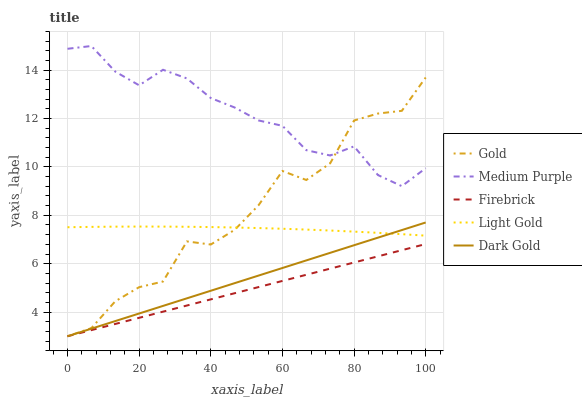Does Firebrick have the minimum area under the curve?
Answer yes or no. Yes. Does Medium Purple have the maximum area under the curve?
Answer yes or no. Yes. Does Light Gold have the minimum area under the curve?
Answer yes or no. No. Does Light Gold have the maximum area under the curve?
Answer yes or no. No. Is Dark Gold the smoothest?
Answer yes or no. Yes. Is Gold the roughest?
Answer yes or no. Yes. Is Firebrick the smoothest?
Answer yes or no. No. Is Firebrick the roughest?
Answer yes or no. No. Does Firebrick have the lowest value?
Answer yes or no. Yes. Does Light Gold have the lowest value?
Answer yes or no. No. Does Medium Purple have the highest value?
Answer yes or no. Yes. Does Light Gold have the highest value?
Answer yes or no. No. Is Dark Gold less than Medium Purple?
Answer yes or no. Yes. Is Light Gold greater than Firebrick?
Answer yes or no. Yes. Does Gold intersect Dark Gold?
Answer yes or no. Yes. Is Gold less than Dark Gold?
Answer yes or no. No. Is Gold greater than Dark Gold?
Answer yes or no. No. Does Dark Gold intersect Medium Purple?
Answer yes or no. No. 